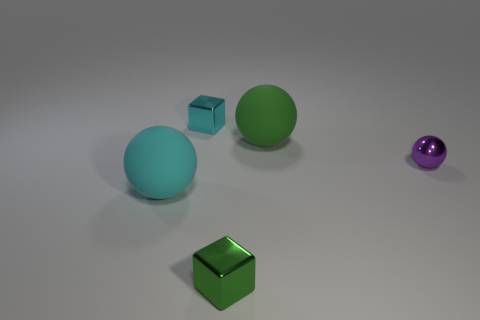There is a ball on the left side of the big rubber thing that is to the right of the cyan metal thing; what is its color? cyan 